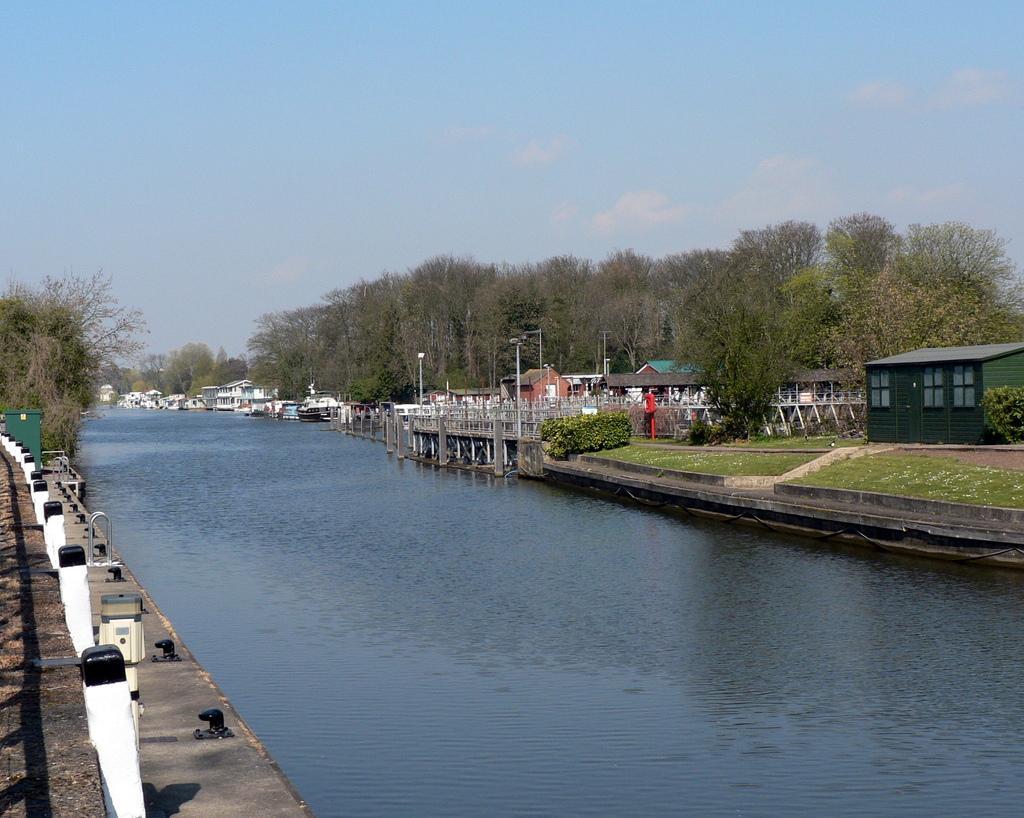Can you describe this image briefly? In the center of the picture there is a canal. On the left side there are poles, pavement and trees. In the background there are trees and boats. On the right side there are trees, lights, buildings, plants, grass, railing and other objects. Sky is clear and it is sunny. 